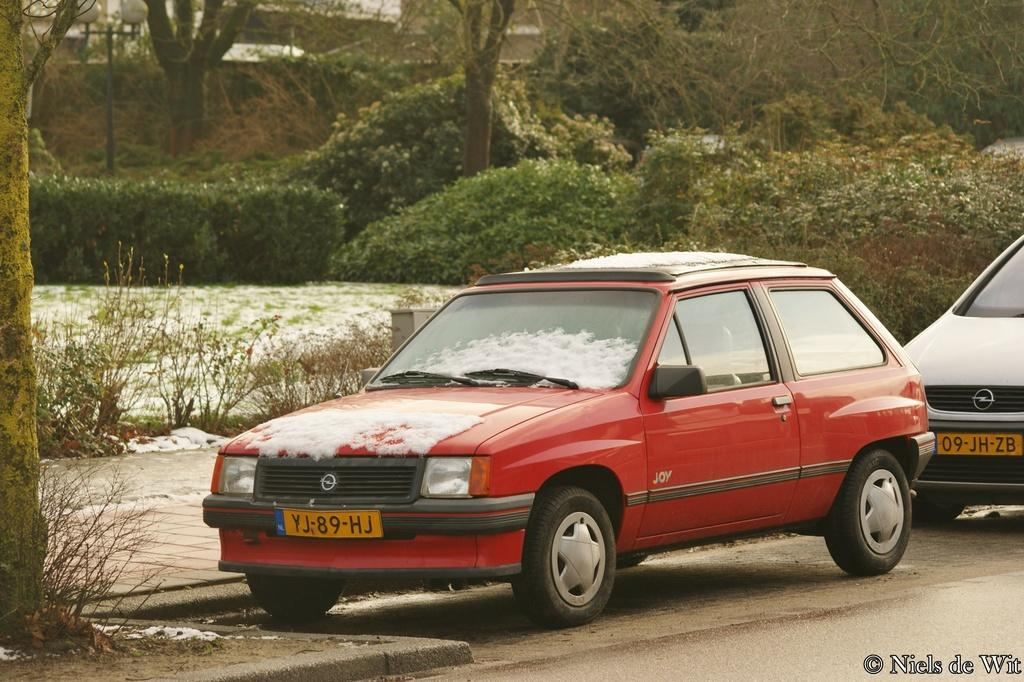<image>
Summarize the visual content of the image. A red car displays an orange license plate with YJ-89-HJ.. 